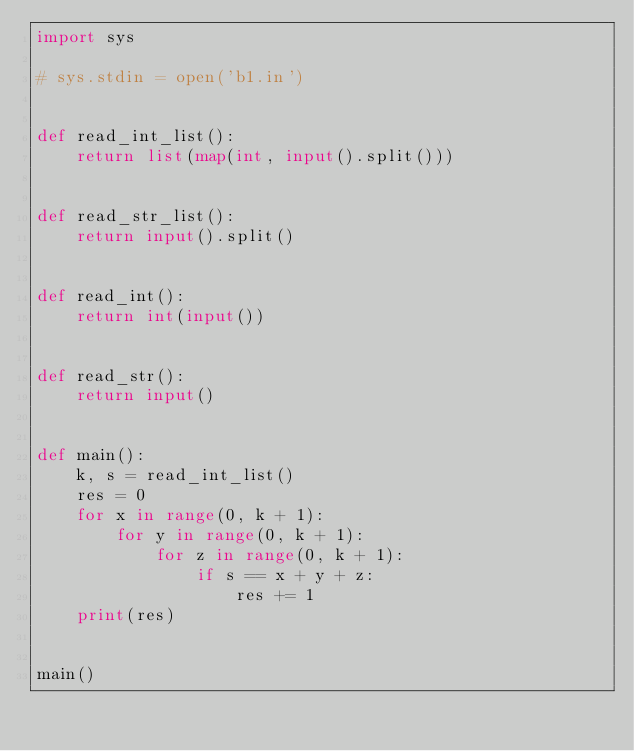Convert code to text. <code><loc_0><loc_0><loc_500><loc_500><_Python_>import sys

# sys.stdin = open('b1.in')


def read_int_list():
    return list(map(int, input().split()))


def read_str_list():
    return input().split()


def read_int():
    return int(input())


def read_str():
    return input()


def main():
    k, s = read_int_list()
    res = 0
    for x in range(0, k + 1):
        for y in range(0, k + 1):
            for z in range(0, k + 1):
                if s == x + y + z:
                    res += 1
    print(res)


main()
</code> 